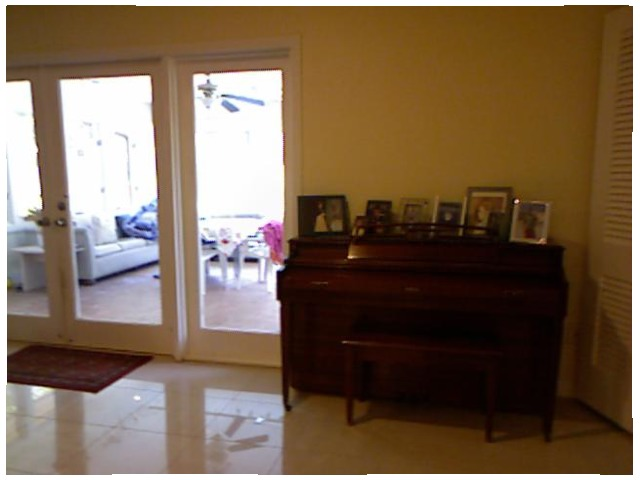<image>
Can you confirm if the door is in front of the couch? Yes. The door is positioned in front of the couch, appearing closer to the camera viewpoint. Where is the couch in relation to the rug? Is it on the rug? No. The couch is not positioned on the rug. They may be near each other, but the couch is not supported by or resting on top of the rug. Is there a picture above the piano? No. The picture is not positioned above the piano. The vertical arrangement shows a different relationship. Is there a ceiling fan in the patio? Yes. The ceiling fan is contained within or inside the patio, showing a containment relationship. 